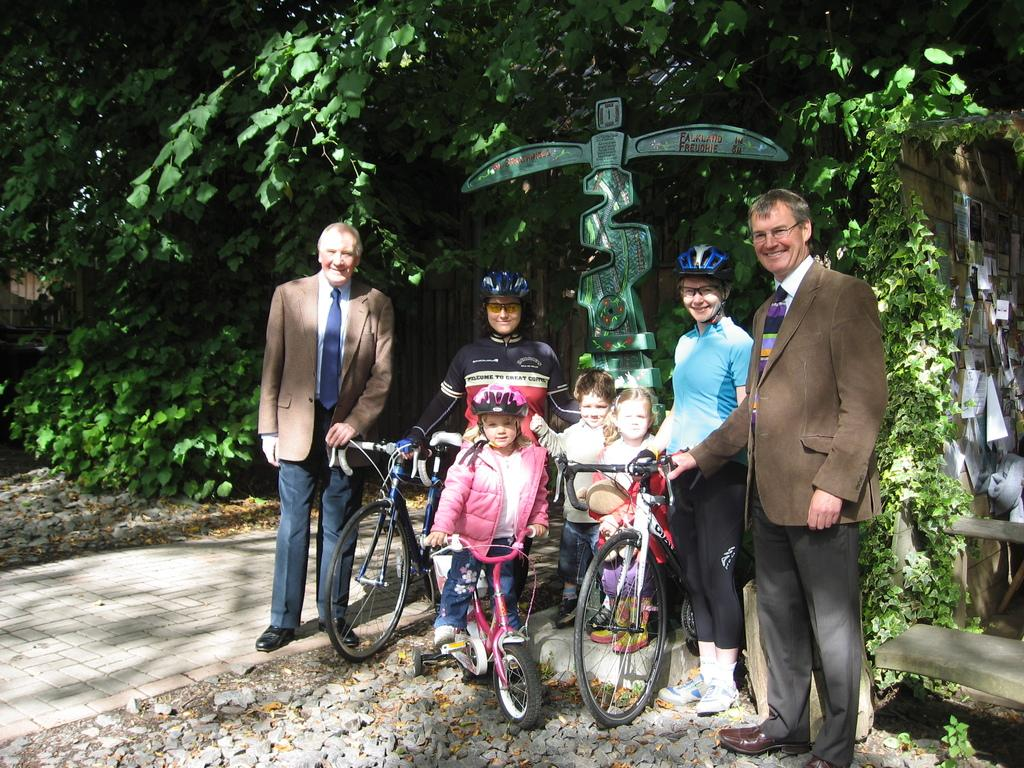What are the people in the image doing? The people in the image are standing. What are some of the people holding? Some people are holding bicycles. What other object can be seen in the image? There is a sculpture in the image. What type of vegetation is visible in the image? Trees are present at the back of the image. What type of feather can be seen on the desk in the image? There is no desk or feather present in the image. 